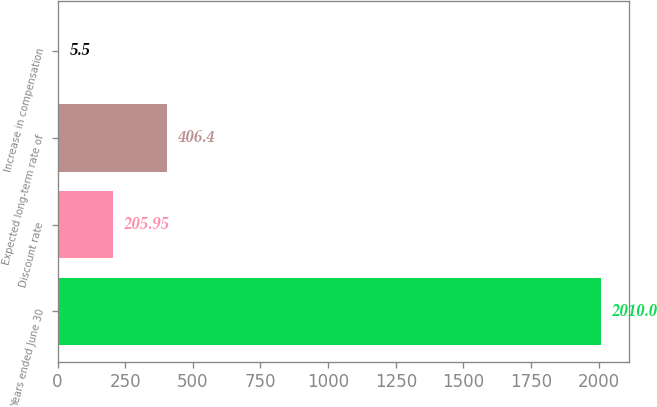<chart> <loc_0><loc_0><loc_500><loc_500><bar_chart><fcel>Years ended June 30<fcel>Discount rate<fcel>Expected long-term rate of<fcel>Increase in compensation<nl><fcel>2010<fcel>205.95<fcel>406.4<fcel>5.5<nl></chart> 